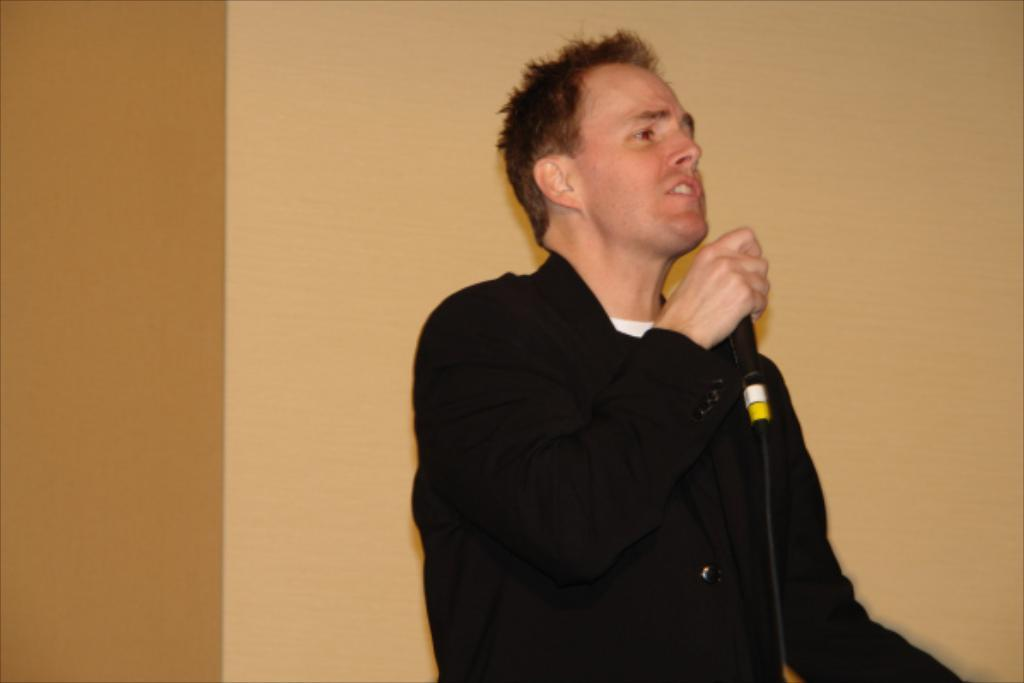What is the main subject of the image? There is a person in the image. What is the person holding in his hand? The person is holding a microphone in his hand. What type of button can be seen on the person's shirt in the image? There is no button visible on the person's shirt in the image. Can you hear the person whistling in the image? There is no sound in the image, so it is not possible to determine if the person is whistling. 